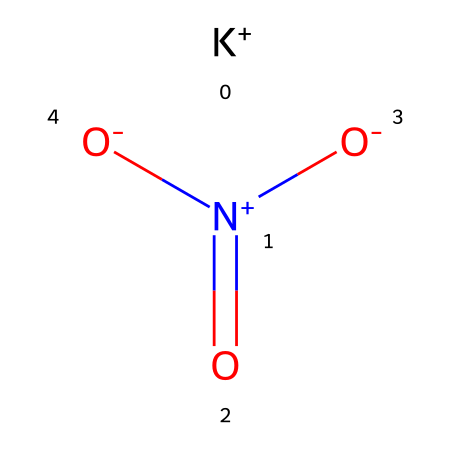What is the full chemical name of this compound? The structure provided corresponds to potassium nitrate, which is the systematic name for the compound represented by the given SMILES notation.
Answer: potassium nitrate How many oxygen atoms are present in the structure? By analyzing the structural formula, there are three oxygen atoms attached to the nitrogen atom in the compound.
Answer: three What is the charge of the potassium ion in this chemical? The SMILES indicates a potassium ion is present with a positive charge, as denoted by [K+]. Thus, the charge is +1.
Answer: +1 What type of compound is potassium nitrate classified as? Potassium nitrate is classified as a salt, formed from the interaction of potassium and nitrate anions.
Answer: salt How many total atoms are in the potassium nitrate molecule? The molecule consists of 1 potassium atom, 1 nitrogen atom, and 3 oxygen atoms, totaling 5 atoms.
Answer: five Which part of the chemical structure indicates its potential use in food preservation? The presence of the nitrate group in the formula is indicative of its potential use as a preservative, as nitrates are commonly utilized for inhibiting spoilage in foods.
Answer: nitrate group Is potassium nitrate considered a fungicide? Potassium nitrate is not classified as a fungicide, although it has properties that may inhibit some microbial growth; it is primarily used as a fertilizer and preservative.
Answer: no 